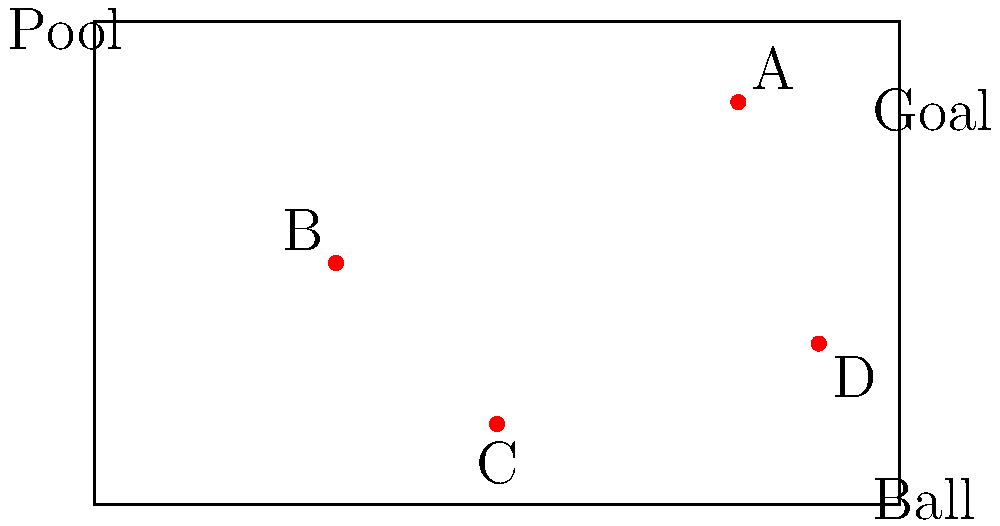In the diagram above, which ball position would be most advantageous for a quick shot on goal? To determine the most advantageous ball position for a quick shot on goal, we need to consider several factors:

1. Distance from the goal: The closer the ball is to the goal, the higher the chances of scoring.
2. Angle to the goal: A position that provides a wider angle to the goal is more advantageous.
3. Defensive pressure: Positions farther from defenders are generally better for shooting.

Let's analyze each ball position:

A: Located at the top right corner, it's far from the goal and likely under defensive pressure.
B: In the middle of the pool, it's far from the goal and doesn't offer a good shooting angle.
C: At the bottom center, it's far from the goal and in a difficult position for shooting.
D: Close to the goal on the right side, offering a good angle and likely less defensive pressure.

Considering these factors, ball D is in the most advantageous position for a quick shot on goal. It's closest to the goal, offers a good shooting angle, and is likely in a position with less immediate defensive pressure.
Answer: D 